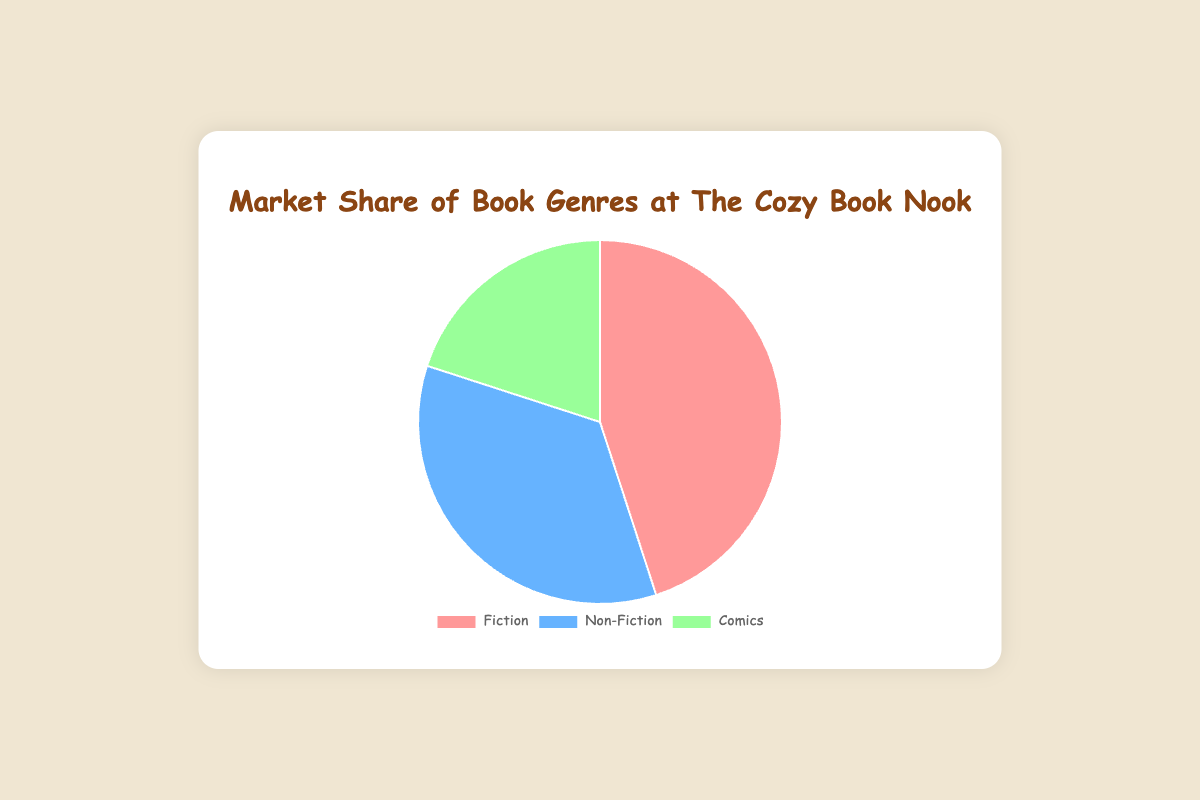What is the market share percentage of Fiction books? The pie chart shows the market share percentage for each genre. Fiction books take up 45%.
Answer: 45% Which genre has the smallest market share? By looking at the pie chart, we can see that Comics have the smallest segment.
Answer: Comics What is the difference in market share between Fiction and Non-Fiction books? The market share for Fiction is 45%, and for Non-Fiction, it is 35%. So, the difference is 45% - 35% = 10%.
Answer: 10% What is the total market share percentage for Non-Fiction and Comics combined? The market share for Non-Fiction is 35%, and for Comics, it is 20%. Adding them together gives 35% + 20% = 55%.
Answer: 55% Which genre has more market share: Comics or Non-Fiction? By looking at the pie chart, Non-Fiction has 35% and Comics have 20%. So, Non-Fiction has more market share.
Answer: Non-Fiction How many example books are listed for the Fiction genre? The data mentions that there are three example books for Fiction: "To Kill a Mockingbird", "1984", "The Great Gatsby".
Answer: 3 If another genre were added with a market share of 15%, what would be the new total market share for all genres combined? The current total market share percentage is 100%. Adding an additional genre with 15% would make it 100% + 15% = 115%.
Answer: 115% What is the sum of the market share percentages for Fiction and Comics? The market share for Fiction is 45%, and for Comics, it is 20%. Adding them together gives 45% + 20% = 65%.
Answer: 65% What color represents the Non-Fiction genre in the pie chart? The pie chart uses blue to represent the Non-Fiction genre.
Answer: Blue Which genre has the highest market share? The pie chart shows that Fiction has the highest market share with 45%.
Answer: Fiction 